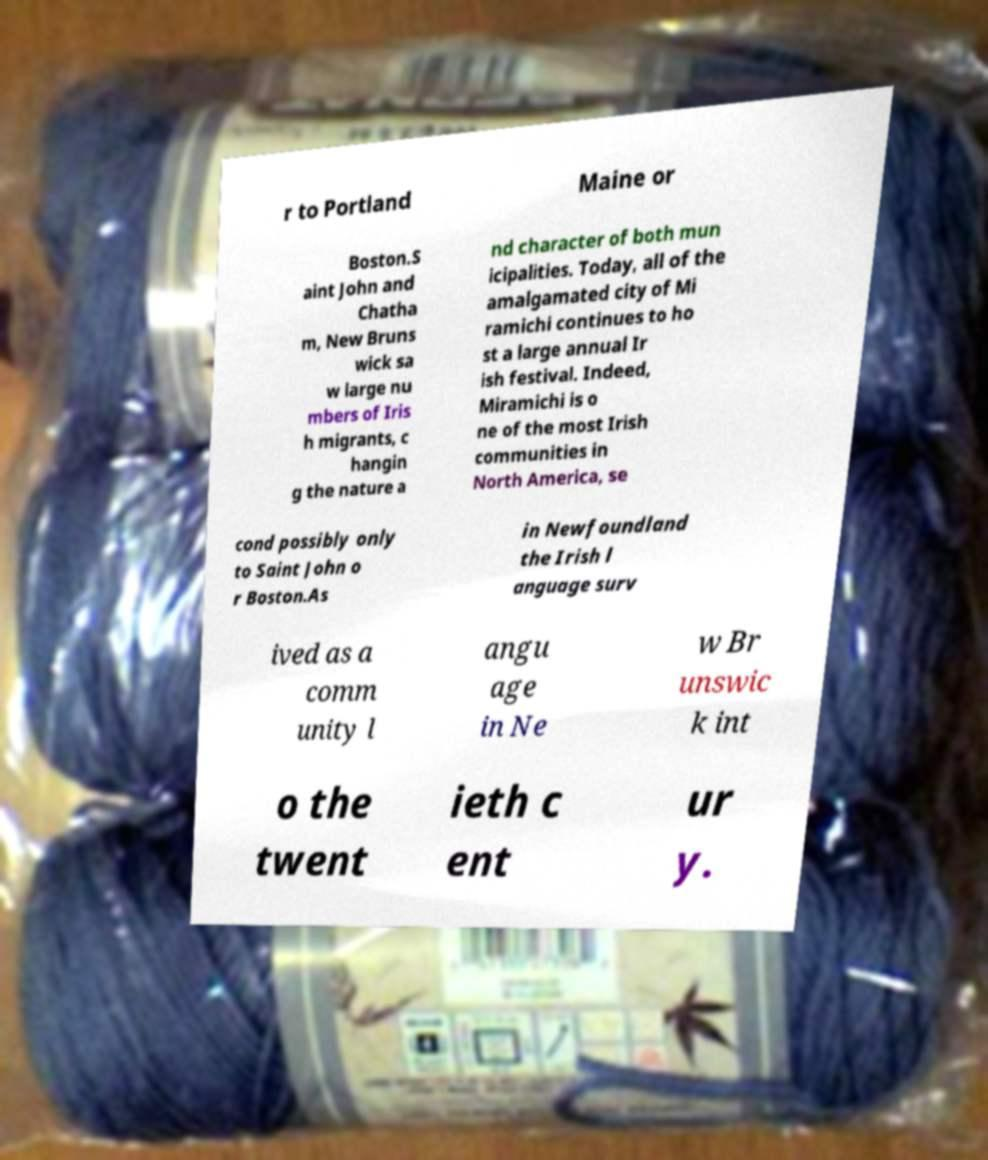Could you extract and type out the text from this image? r to Portland Maine or Boston.S aint John and Chatha m, New Bruns wick sa w large nu mbers of Iris h migrants, c hangin g the nature a nd character of both mun icipalities. Today, all of the amalgamated city of Mi ramichi continues to ho st a large annual Ir ish festival. Indeed, Miramichi is o ne of the most Irish communities in North America, se cond possibly only to Saint John o r Boston.As in Newfoundland the Irish l anguage surv ived as a comm unity l angu age in Ne w Br unswic k int o the twent ieth c ent ur y. 